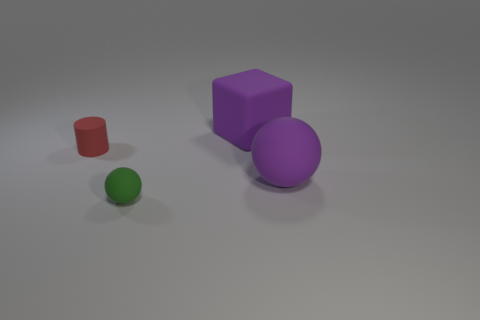Do the small green thing and the big purple rubber object in front of the big purple rubber cube have the same shape?
Offer a very short reply. Yes. What size is the rubber thing that is on the left side of the big rubber cube and to the right of the red rubber cylinder?
Offer a very short reply. Small. What is the shape of the red matte thing?
Offer a very short reply. Cylinder. There is a tiny matte thing on the right side of the tiny cylinder; is there a green thing in front of it?
Your response must be concise. No. What number of purple matte blocks are behind the large matte object that is to the left of the purple rubber ball?
Ensure brevity in your answer.  0. There is a object that is the same size as the matte block; what is it made of?
Keep it short and to the point. Rubber. There is a purple rubber object that is right of the large matte block; is its shape the same as the red object?
Provide a succinct answer. No. Is the number of big purple things right of the tiny sphere greater than the number of objects in front of the cylinder?
Offer a terse response. No. What number of big balls are made of the same material as the small ball?
Provide a short and direct response. 1. Does the red thing have the same size as the block?
Your answer should be very brief. No. 